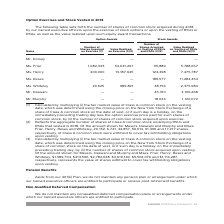According to Square's financial document, What does the table show? the number of shares of common stock acquired during 2018 by our named executive officers upon the exercise of stock options or upon the vesting of RSUs or RSAs, as well as the value realized upon such equity award transactions.. The document states: "The following table sets forth the number of shares of common stock acquired during 2018 by our named executive officers upon the exercise of stock op..." Also, What does the Number of Shares Acquired on Vesting of RSUs and RSAs column show? Reflects the aggregate number of shares of Class A common stock underlying RSUs and RSAs that vested in 2018.. The document states: "shares of common stock acquired upon exercise. (2) Reflects the aggregate number of shares of Class A common stock underlying RSUs and RSAs that veste..." Also, What is the Number of Shares Acquired on Exercise for Ms Friar? According to the financial document, 1,082,343. The relevant text states: "Ms. Friar 1,082,343 54,631,297 95,889 5,788,657..." Also, can you calculate: What is the average Number of Shares Acquired on Exercise for the 3 officers who received it? To answer this question, I need to perform calculations using the financial data. The calculation is: (1,082,343 + 200,000 + 20,625) / 3 , which equals 434322.67. This is based on the information: "Ms. Friar 1,082,343 54,631,297 95,889 5,788,657 Ms. Whiteley 20,625 989,821 38,156 2,375,984 Ms. Henry 200,000 13,187,645 124,498 7,475,787..." The key data points involved are: 1,082,343, 20,625, 200,000. Also, can you calculate: What is the difference between the largest and smallest Value Realized on Vesting of RSUs and RSAs? Based on the calculation: 11,284,454 - 1,120,072 , the result is 10164382. This is based on the information: "Mr. Murphy — — 18,024 1,120,072 Ms. Reses — — 189,577 11,284,454..." The key data points involved are: 1,120,072, 11,284,454. Additionally, Who has the largest amount of  Number of Shares Acquired on Vesting of RSUs and RSAs? According to the financial document, Ms. Reses. The relevant text states: "Ms. Reses — — 189,577 11,284,454..." 